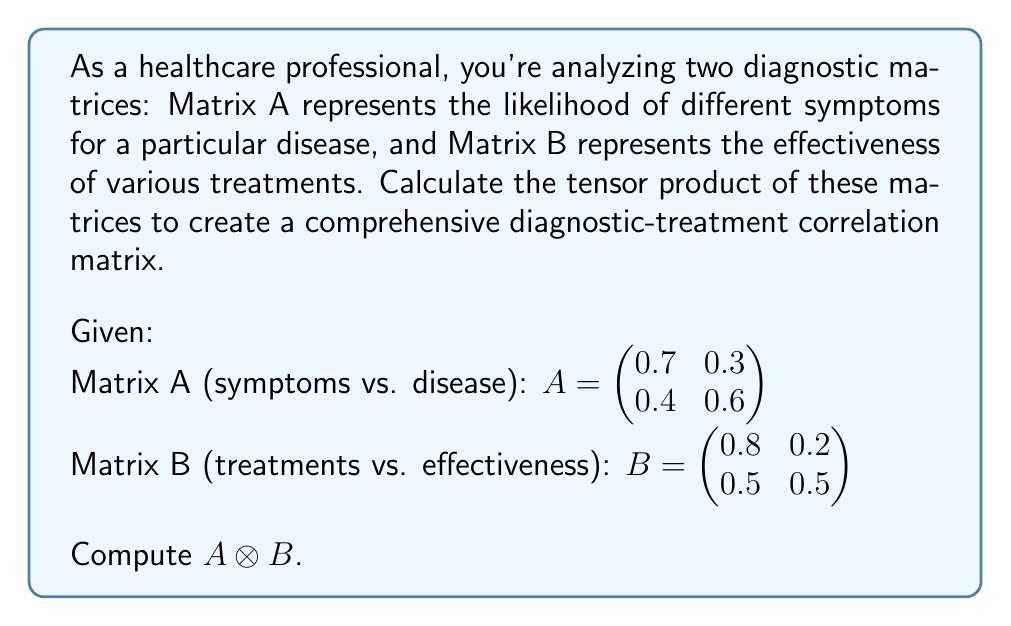What is the answer to this math problem? To compute the tensor product $A \otimes B$, we follow these steps:

1) The tensor product of two matrices results in a block matrix where each element of the first matrix is multiplied by the entire second matrix.

2) For a 2x2 matrix A and a 2x2 matrix B, the result will be a 4x4 matrix.

3) Let's compute each block:

   For $a_{11} = 0.7$:
   $0.7 \cdot B = \begin{pmatrix} 0.7 \cdot 0.8 & 0.7 \cdot 0.2 \\ 0.7 \cdot 0.5 & 0.7 \cdot 0.5 \end{pmatrix} = \begin{pmatrix} 0.56 & 0.14 \\ 0.35 & 0.35 \end{pmatrix}$

   For $a_{12} = 0.3$:
   $0.3 \cdot B = \begin{pmatrix} 0.3 \cdot 0.8 & 0.3 \cdot 0.2 \\ 0.3 \cdot 0.5 & 0.3 \cdot 0.5 \end{pmatrix} = \begin{pmatrix} 0.24 & 0.06 \\ 0.15 & 0.15 \end{pmatrix}$

   For $a_{21} = 0.4$:
   $0.4 \cdot B = \begin{pmatrix} 0.4 \cdot 0.8 & 0.4 \cdot 0.2 \\ 0.4 \cdot 0.5 & 0.4 \cdot 0.5 \end{pmatrix} = \begin{pmatrix} 0.32 & 0.08 \\ 0.20 & 0.20 \end{pmatrix}$

   For $a_{22} = 0.6$:
   $0.6 \cdot B = \begin{pmatrix} 0.6 \cdot 0.8 & 0.6 \cdot 0.2 \\ 0.6 \cdot 0.5 & 0.6 \cdot 0.5 \end{pmatrix} = \begin{pmatrix} 0.48 & 0.12 \\ 0.30 & 0.30 \end{pmatrix}$

4) Now, we arrange these blocks into the final 4x4 matrix:

   $A \otimes B = \begin{pmatrix} 
   0.56 & 0.14 & 0.24 & 0.06 \\
   0.35 & 0.35 & 0.15 & 0.15 \\
   0.32 & 0.08 & 0.48 & 0.12 \\
   0.20 & 0.20 & 0.30 & 0.30
   \end{pmatrix}$

This resulting matrix provides a comprehensive view of how symptoms and treatments correlate, which can be valuable for diagnostic and treatment planning purposes.
Answer: $$A \otimes B = \begin{pmatrix} 
0.56 & 0.14 & 0.24 & 0.06 \\
0.35 & 0.35 & 0.15 & 0.15 \\
0.32 & 0.08 & 0.48 & 0.12 \\
0.20 & 0.20 & 0.30 & 0.30
\end{pmatrix}$$ 